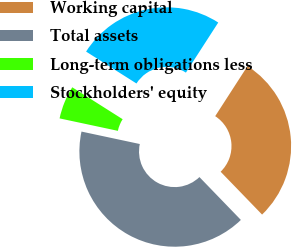<chart> <loc_0><loc_0><loc_500><loc_500><pie_chart><fcel>Working capital<fcel>Total assets<fcel>Long-term obligations less<fcel>Stockholders' equity<nl><fcel>28.64%<fcel>40.58%<fcel>5.64%<fcel>25.14%<nl></chart> 